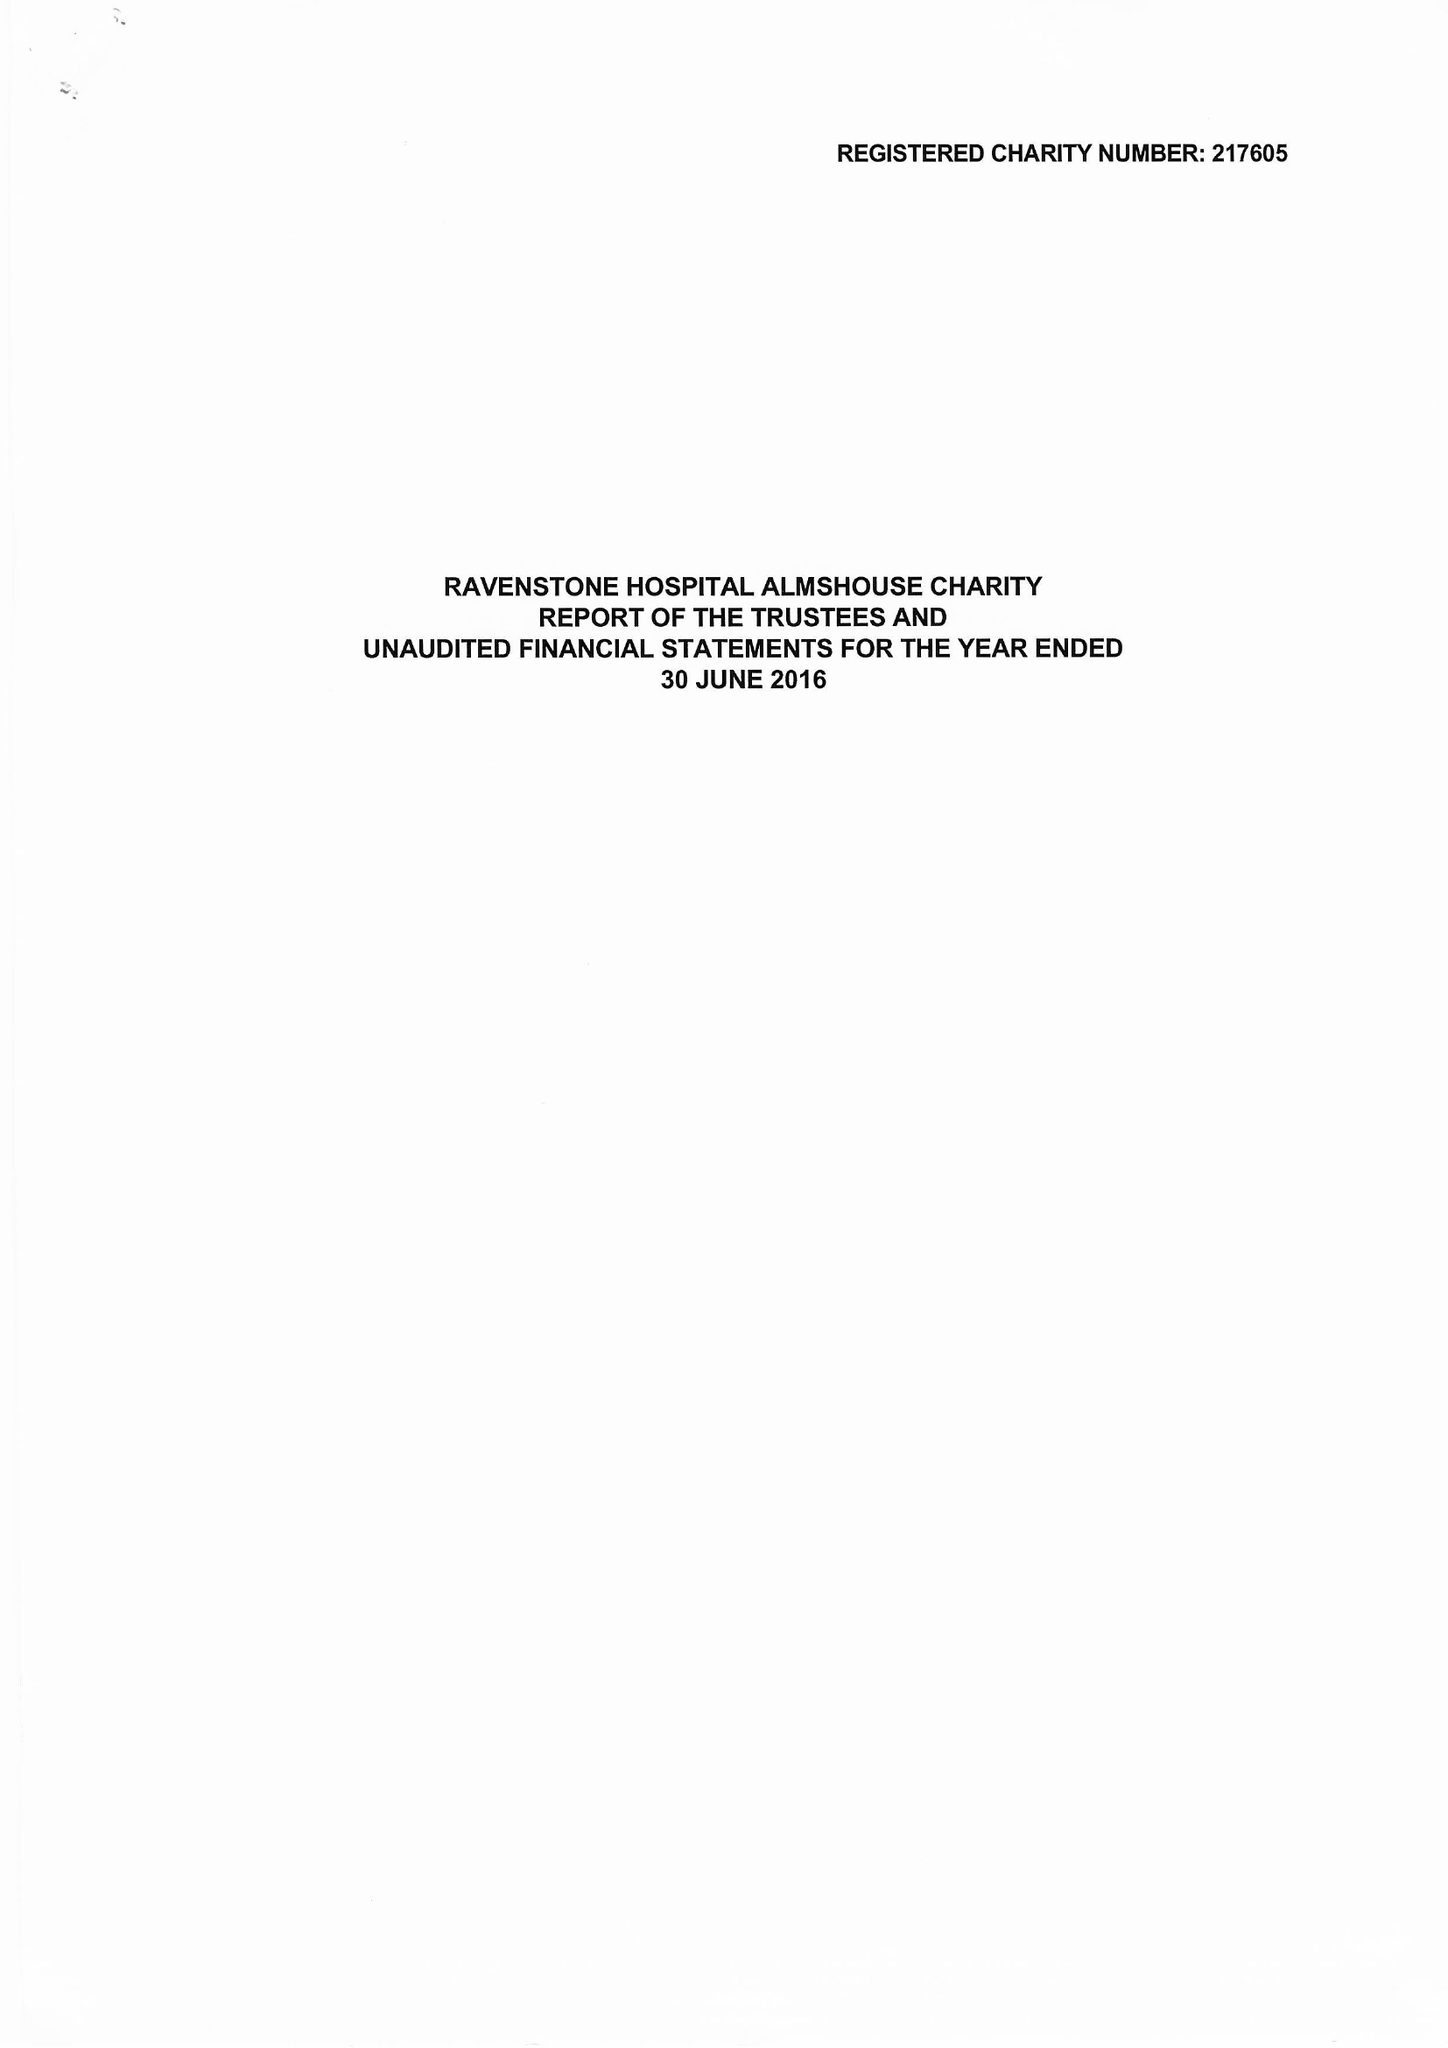What is the value for the income_annually_in_british_pounds?
Answer the question using a single word or phrase. 78861.00 